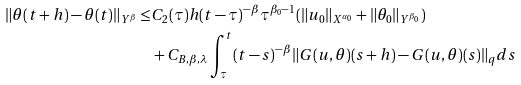Convert formula to latex. <formula><loc_0><loc_0><loc_500><loc_500>\| \theta ( t + h ) - \theta ( t ) \| _ { Y ^ { \beta } } \leq & C _ { 2 } ( \tau ) h ( t - \tau ) ^ { - \beta } \tau ^ { \beta _ { 0 } - 1 } ( \| u _ { 0 } \| _ { X ^ { \alpha _ { 0 } } } + \| \theta _ { 0 } \| _ { Y ^ { \beta _ { 0 } } } ) \\ & + C _ { B , \beta , \lambda } \int ^ { t } _ { \tau } ( t - s ) ^ { - \beta } \| G ( u , \theta ) ( s + h ) - G ( u , \theta ) ( s ) \| _ { q } d s</formula> 